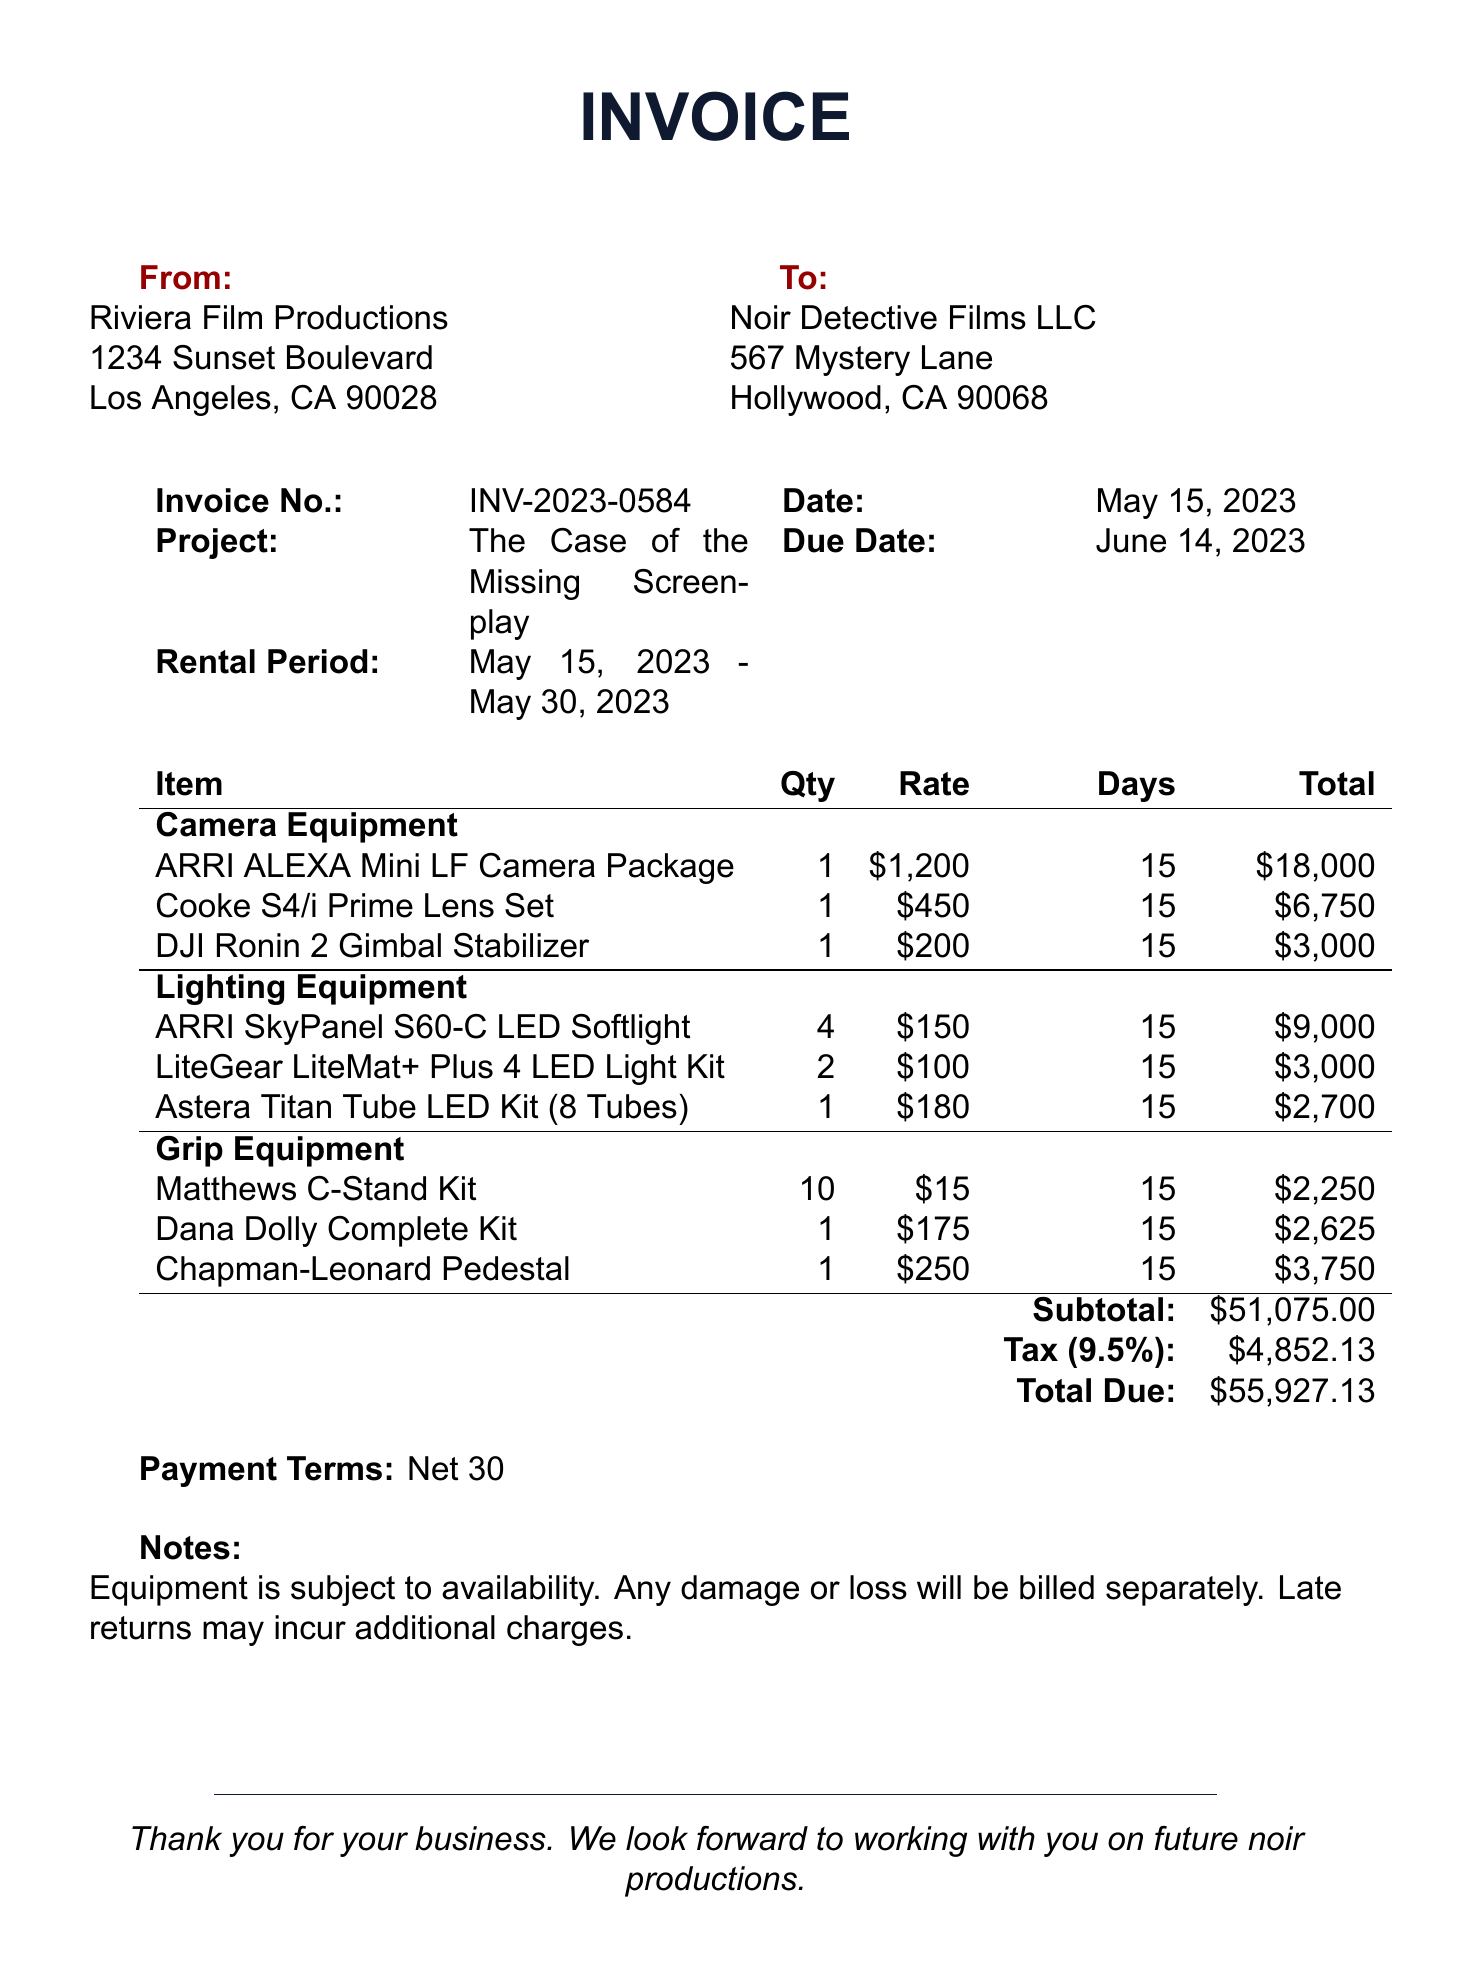What is the invoice number? The invoice number is specified in the document as a distinct identifier for this invoice.
Answer: INV-2023-0584 What is the date of the invoice? The date of the invoice is important for tracking and payment purposes, found in the document under the date section.
Answer: May 15, 2023 What is the total due amount? The total due is the final amount payable, which is clearly stated at the bottom of the invoice.
Answer: 55,927.13 What company is issuing the invoice? The company that issued the invoice is detailed at the top of the document, indicating who is providing the service.
Answer: Riviera Film Productions How many days is the rental period? The rental period is listed in the document, and calculating the total number of days helps clarify the rental terms.
Answer: 15 What category does the "Cooke S4/i Prime Lens Set" belong to? Each item is categorized in the document, which helps identify the type of equipment rented.
Answer: Camera Equipment What is the tax rate applied to the invoice? The tax rate is specified in the document, which is essential for calculating the total amount due.
Answer: 9.5% Which item has the highest total cost? The total cost of each item is summed up, and identifying the highest cost helps understand rental charges.
Answer: ARRI ALEXA Mini LF Camera Package What payment terms are specified in the invoice? Payment terms outline the conditions for payment and are crucial for cash flow management.
Answer: Net 30 